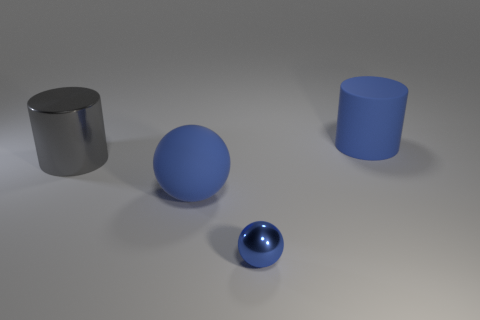Are there fewer tiny blue balls to the left of the large ball than small objects that are to the right of the small metal object?
Offer a very short reply. No. There is a large cylinder behind the gray cylinder; what material is it?
Offer a terse response. Rubber. There is a thing that is both in front of the big gray shiny cylinder and behind the metallic sphere; what color is it?
Ensure brevity in your answer.  Blue. What number of other objects are the same color as the big ball?
Provide a succinct answer. 2. What color is the big matte thing that is behind the gray metallic thing?
Keep it short and to the point. Blue. Is there another rubber cylinder of the same size as the blue rubber cylinder?
Provide a succinct answer. No. There is a blue thing that is the same size as the blue rubber ball; what material is it?
Your answer should be compact. Rubber. What number of things are either big objects behind the gray shiny cylinder or blue objects that are left of the large blue matte cylinder?
Provide a short and direct response. 3. Is there a large rubber thing of the same shape as the tiny blue object?
Give a very brief answer. Yes. What is the material of the sphere that is the same color as the tiny thing?
Ensure brevity in your answer.  Rubber. 